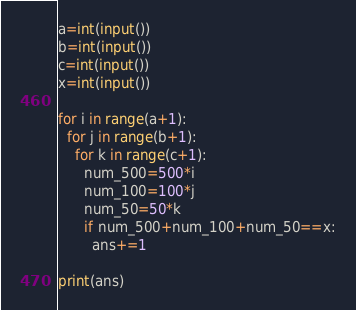Convert code to text. <code><loc_0><loc_0><loc_500><loc_500><_Python_>a=int(input())
b=int(input())
c=int(input())
x=int(input())

for i in range(a+1):
  for j in range(b+1):
    for k in range(c+1):
      num_500=500*i
      num_100=100*j
      num_50=50*k
      if num_500+num_100+num_50==x:
        ans+=1
        
print(ans)
</code> 